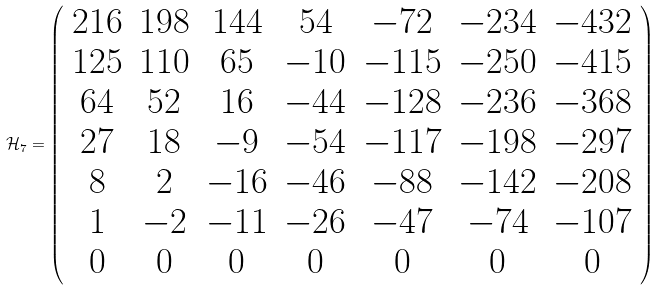Convert formula to latex. <formula><loc_0><loc_0><loc_500><loc_500>\mathcal { H } _ { 7 } = \left ( \begin{array} { c c c c c c c } 2 1 6 & 1 9 8 & 1 4 4 & 5 4 & - 7 2 & - 2 3 4 & - 4 3 2 \\ 1 2 5 & 1 1 0 & 6 5 & - 1 0 & - 1 1 5 & - 2 5 0 & - 4 1 5 \\ 6 4 & 5 2 & 1 6 & - 4 4 & - 1 2 8 & - 2 3 6 & - 3 6 8 \\ 2 7 & 1 8 & - 9 & - 5 4 & - 1 1 7 & - 1 9 8 & - 2 9 7 \\ 8 & 2 & - 1 6 & - 4 6 & - 8 8 & - 1 4 2 & - 2 0 8 \\ 1 & - 2 & - 1 1 & - 2 6 & - 4 7 & - 7 4 & - 1 0 7 \\ 0 & 0 & 0 & 0 & 0 & 0 & 0 \\ \end{array} \right )</formula> 